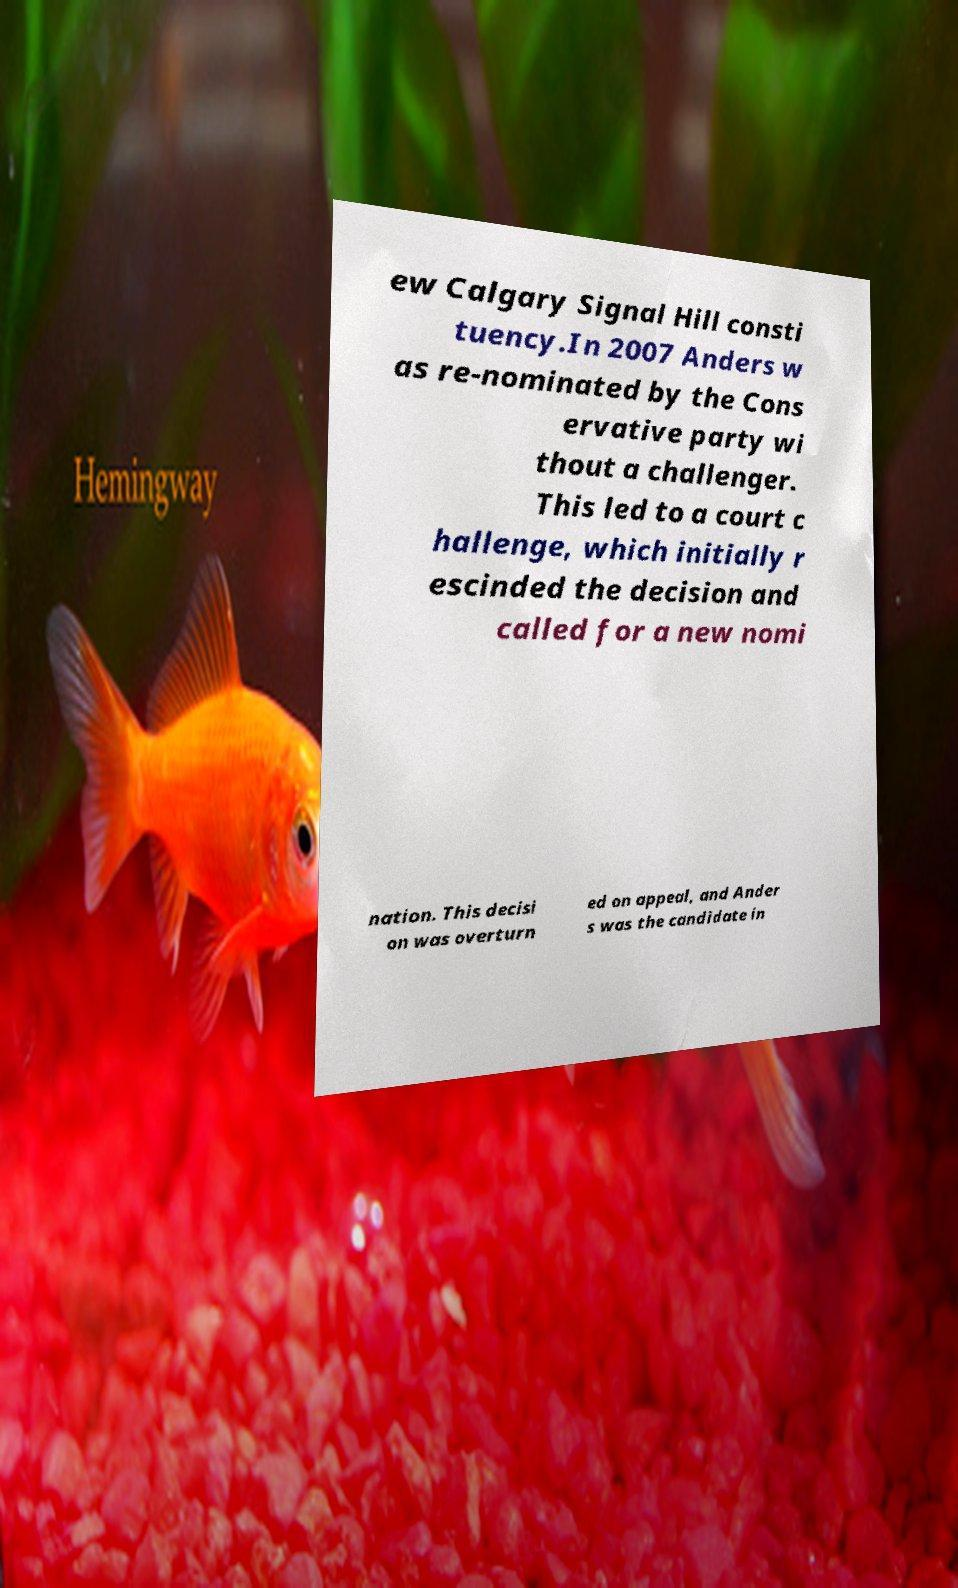Could you assist in decoding the text presented in this image and type it out clearly? ew Calgary Signal Hill consti tuency.In 2007 Anders w as re-nominated by the Cons ervative party wi thout a challenger. This led to a court c hallenge, which initially r escinded the decision and called for a new nomi nation. This decisi on was overturn ed on appeal, and Ander s was the candidate in 